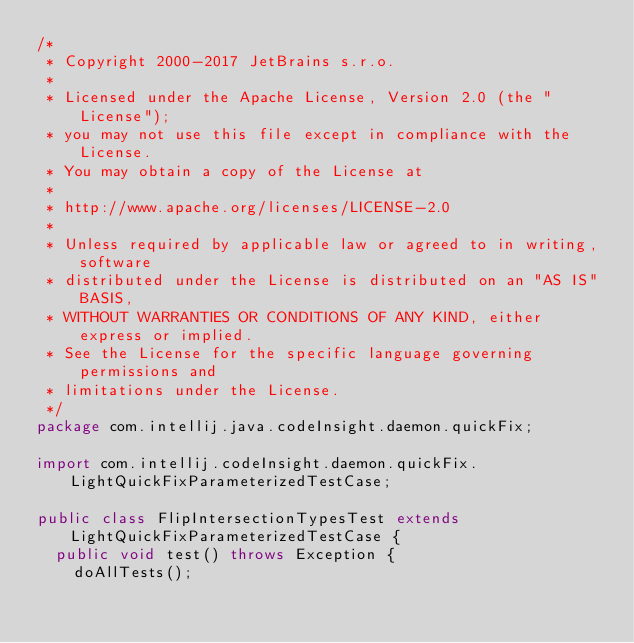Convert code to text. <code><loc_0><loc_0><loc_500><loc_500><_Java_>/*
 * Copyright 2000-2017 JetBrains s.r.o.
 *
 * Licensed under the Apache License, Version 2.0 (the "License");
 * you may not use this file except in compliance with the License.
 * You may obtain a copy of the License at
 *
 * http://www.apache.org/licenses/LICENSE-2.0
 *
 * Unless required by applicable law or agreed to in writing, software
 * distributed under the License is distributed on an "AS IS" BASIS,
 * WITHOUT WARRANTIES OR CONDITIONS OF ANY KIND, either express or implied.
 * See the License for the specific language governing permissions and
 * limitations under the License.
 */
package com.intellij.java.codeInsight.daemon.quickFix;

import com.intellij.codeInsight.daemon.quickFix.LightQuickFixParameterizedTestCase;

public class FlipIntersectionTypesTest extends LightQuickFixParameterizedTestCase {
  public void test() throws Exception {
    doAllTests();</code> 